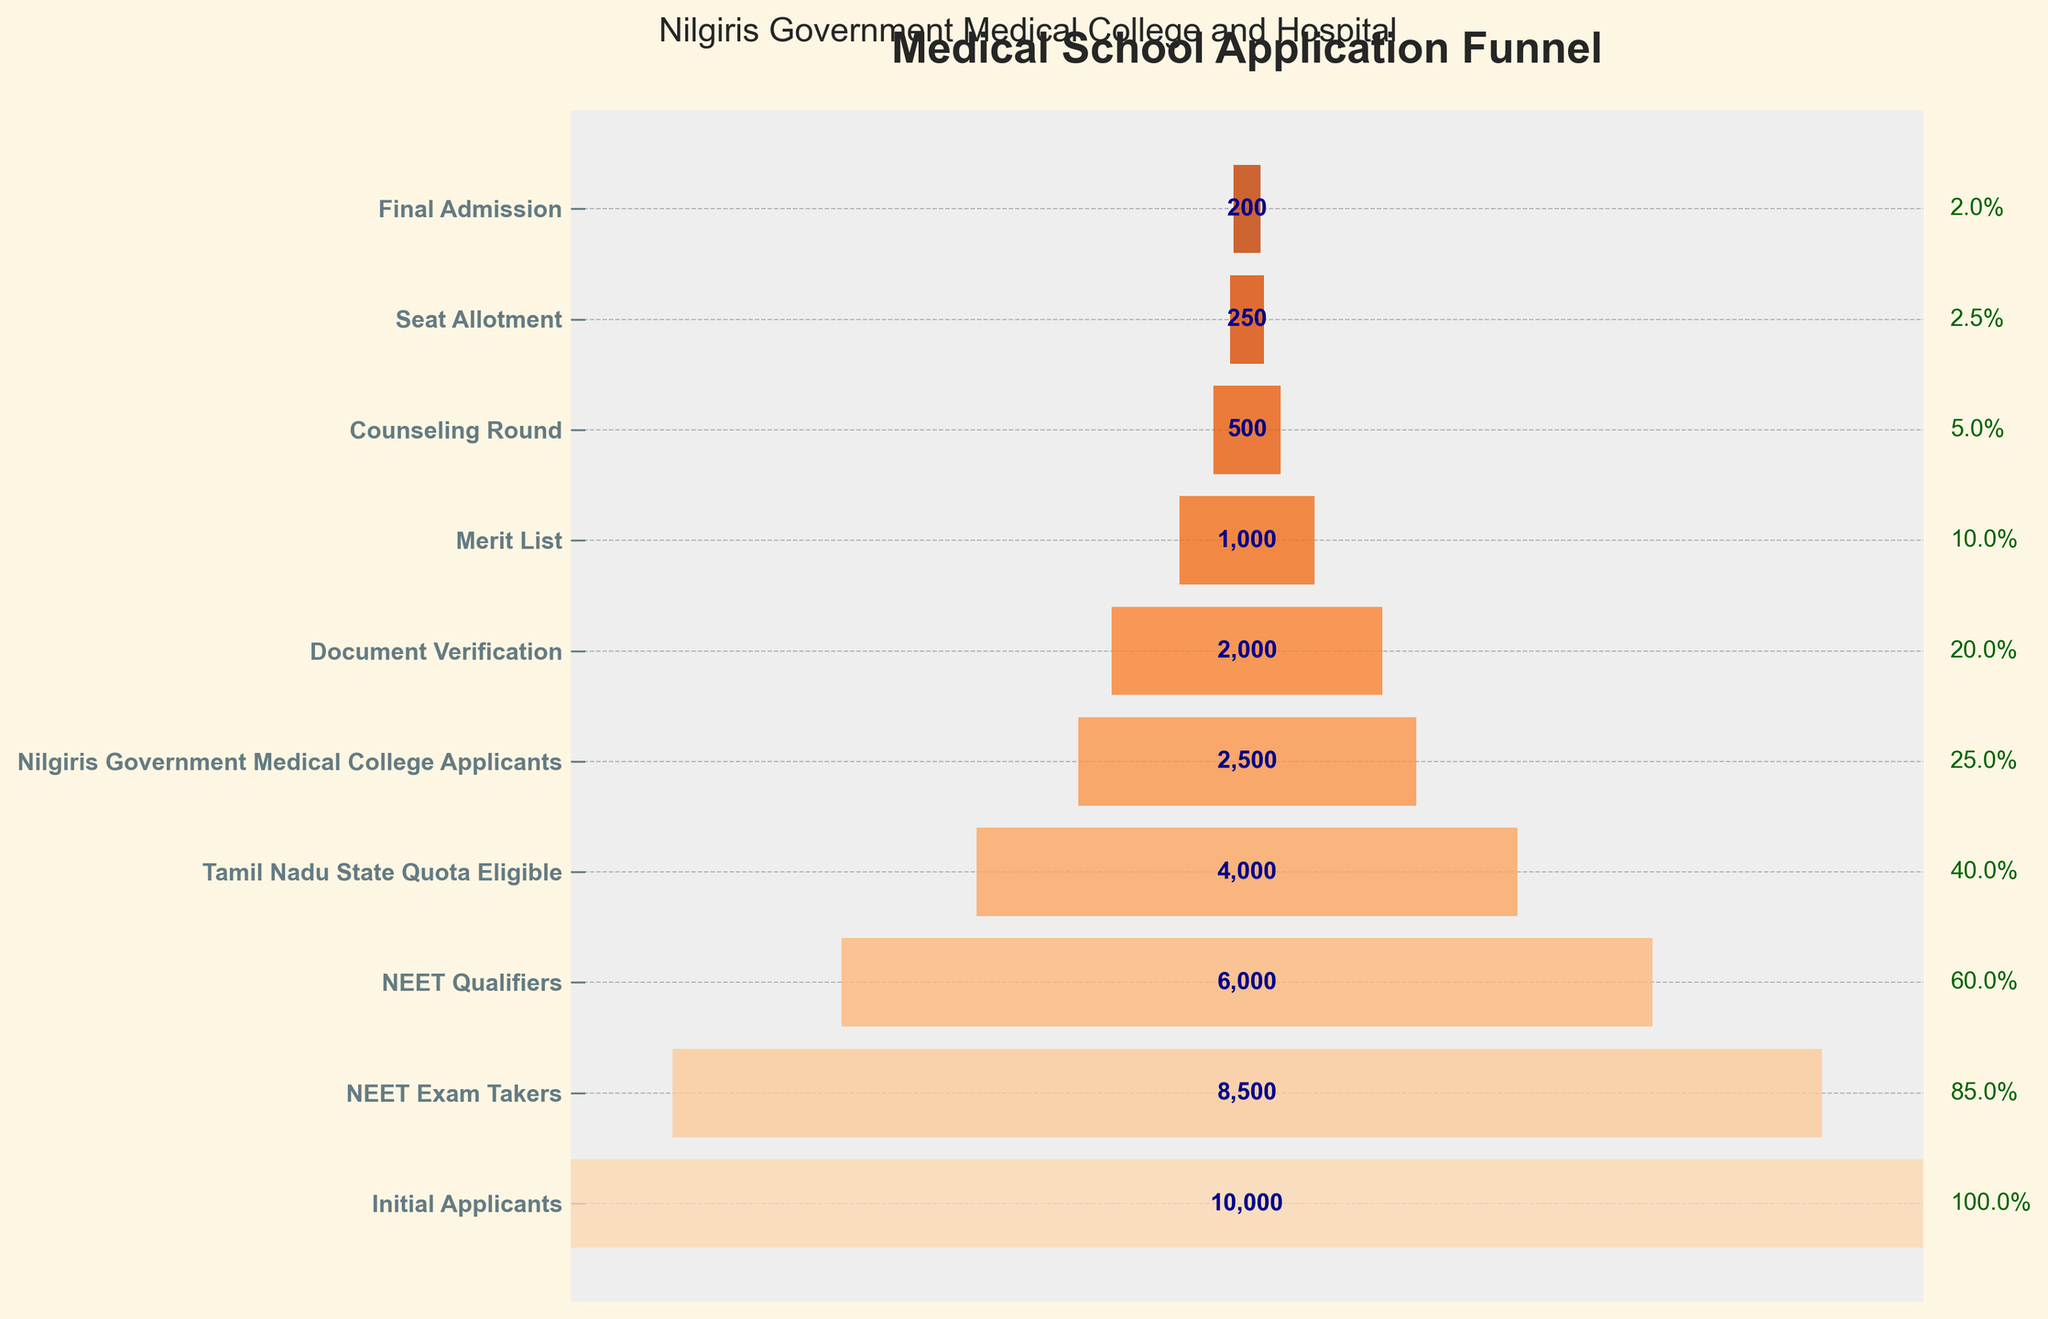What is the title of the funnel chart? The title of the funnel chart is located at the top of the figure and identifies the main subject of the visualization. It reads "Medical School Application Funnel".
Answer: Medical School Application Funnel How many applicants made it to the 'Counseling Round' stage? The 'Counseling Round' stage is one of the levels in the funnel chart where the number of applicants is displayed inside the bar. It shows "500".
Answer: 500 What percentage of 'Initial Applicants' reached the 'Final Admission' stage? The 'Final Admission' stage shows the number of applicants along with the percentage relative to 'Initial Applicants'. It reads "200" applicants and "2.0%". This percentage indicates that 200 out of 10000 initial applicants reached the final stage.
Answer: 2.0% Which stage saw the most significant drop in the number of applicants compared to the previous stage? By examining the differences between successive stages, the largest drop is from 'Document Verification' (2000) to 'Merit List' (1000), where the difference is 1000 applicants.
Answer: From 'Document Verification' to 'Merit List' How many applicants were lost between 'Tamil Nadu State Quota Eligible' and 'Nilgiris Government Medical College Applicants'? To find the number of applicants lost between these stages, subtract the 'Nilgiris Government Medical College Applicants' (2500) from the 'Tamil Nadu State Quota Eligible' (4000). This calculation results in 4000 - 2500 = 1500.
Answer: 1500 What is the overall attrition rate from 'NEET Exam Takers' to 'NEET Qualifiers'? To find the attrition rate, first calculate the difference between 'NEET Exam Takers' (8500) and 'NEET Qualifiers' (6000), which is 8500 - 6000 = 2500. Then, the attrition rate is (2500 / 8500) * 100 = 29.4%.
Answer: 29.4% Which stage has roughly 25% of the 'Initial Applicants'? To find this, look for the stage that retains around 2500 applicants (25% of 10000). The 'Nilgiris Government Medical College Applicants' stage has 2500 applicants.
Answer: Nilgiris Government Medical College Applicants How many stages are there in the funnel chart for the medical school application process? Count the unique stages listed from 'Initial Applicants' to 'Final Admission'. There are 10 stages in total.
Answer: 10 Between which two stages do we see the smallest drop in the number of applicants? Examine the differences between the numbers for each successive stage. The smallest drop is from 'Seat Allotment' (250) to 'Final Admission' (200) with a difference of 50.
Answer: From 'Seat Allotment' to 'Final Admission' Which stage immediately follows the 'Merit List' stage? The stage that comes right after 'Merit List' is 'Counseling Round', as per the sequence presented in the funnel chart.
Answer: Counseling Round 